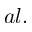<formula> <loc_0><loc_0><loc_500><loc_500>a l .</formula> 